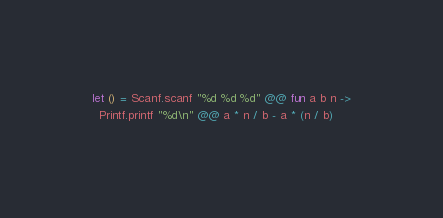<code> <loc_0><loc_0><loc_500><loc_500><_OCaml_>let () = Scanf.scanf "%d %d %d" @@ fun a b n ->
  Printf.printf "%d\n" @@ a * n / b - a * (n / b)
</code> 